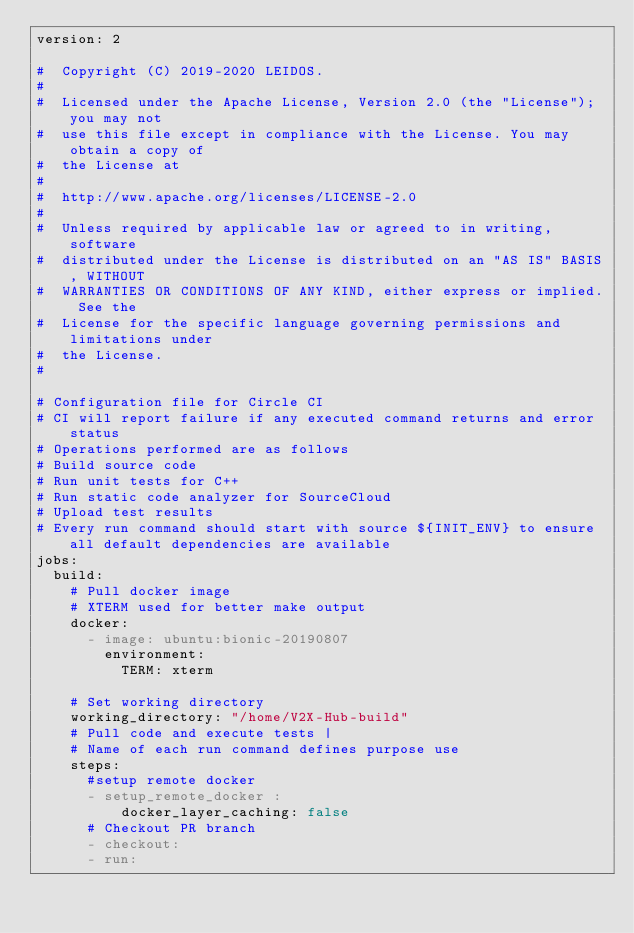<code> <loc_0><loc_0><loc_500><loc_500><_YAML_>version: 2

#  Copyright (C) 2019-2020 LEIDOS.
# 
#  Licensed under the Apache License, Version 2.0 (the "License"); you may not
#  use this file except in compliance with the License. You may obtain a copy of
#  the License at
# 
#  http://www.apache.org/licenses/LICENSE-2.0
# 
#  Unless required by applicable law or agreed to in writing, software
#  distributed under the License is distributed on an "AS IS" BASIS, WITHOUT
#  WARRANTIES OR CONDITIONS OF ANY KIND, either express or implied. See the
#  License for the specific language governing permissions and limitations under
#  the License.
# 

# Configuration file for Circle CI 
# CI will report failure if any executed command returns and error status
# Operations performed are as follows
# Build source code
# Run unit tests for C++ 
# Run static code analyzer for SourceCloud
# Upload test results
# Every run command should start with source ${INIT_ENV} to ensure all default dependencies are available
jobs:
  build:
    # Pull docker image 
    # XTERM used for better make output
    docker:
      - image: ubuntu:bionic-20190807
        environment:
          TERM: xterm
          
    # Set working directory
    working_directory: "/home/V2X-Hub-build"
    # Pull code and execute tests |
    # Name of each run command defines purpose use
    steps:
      #setup remote docker
      - setup_remote_docker :
          docker_layer_caching: false
      # Checkout PR branch
      - checkout:
      - run: </code> 